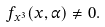Convert formula to latex. <formula><loc_0><loc_0><loc_500><loc_500>{ f _ { x ^ { 3 } } } ( x , \alpha ) \not = 0 .</formula> 